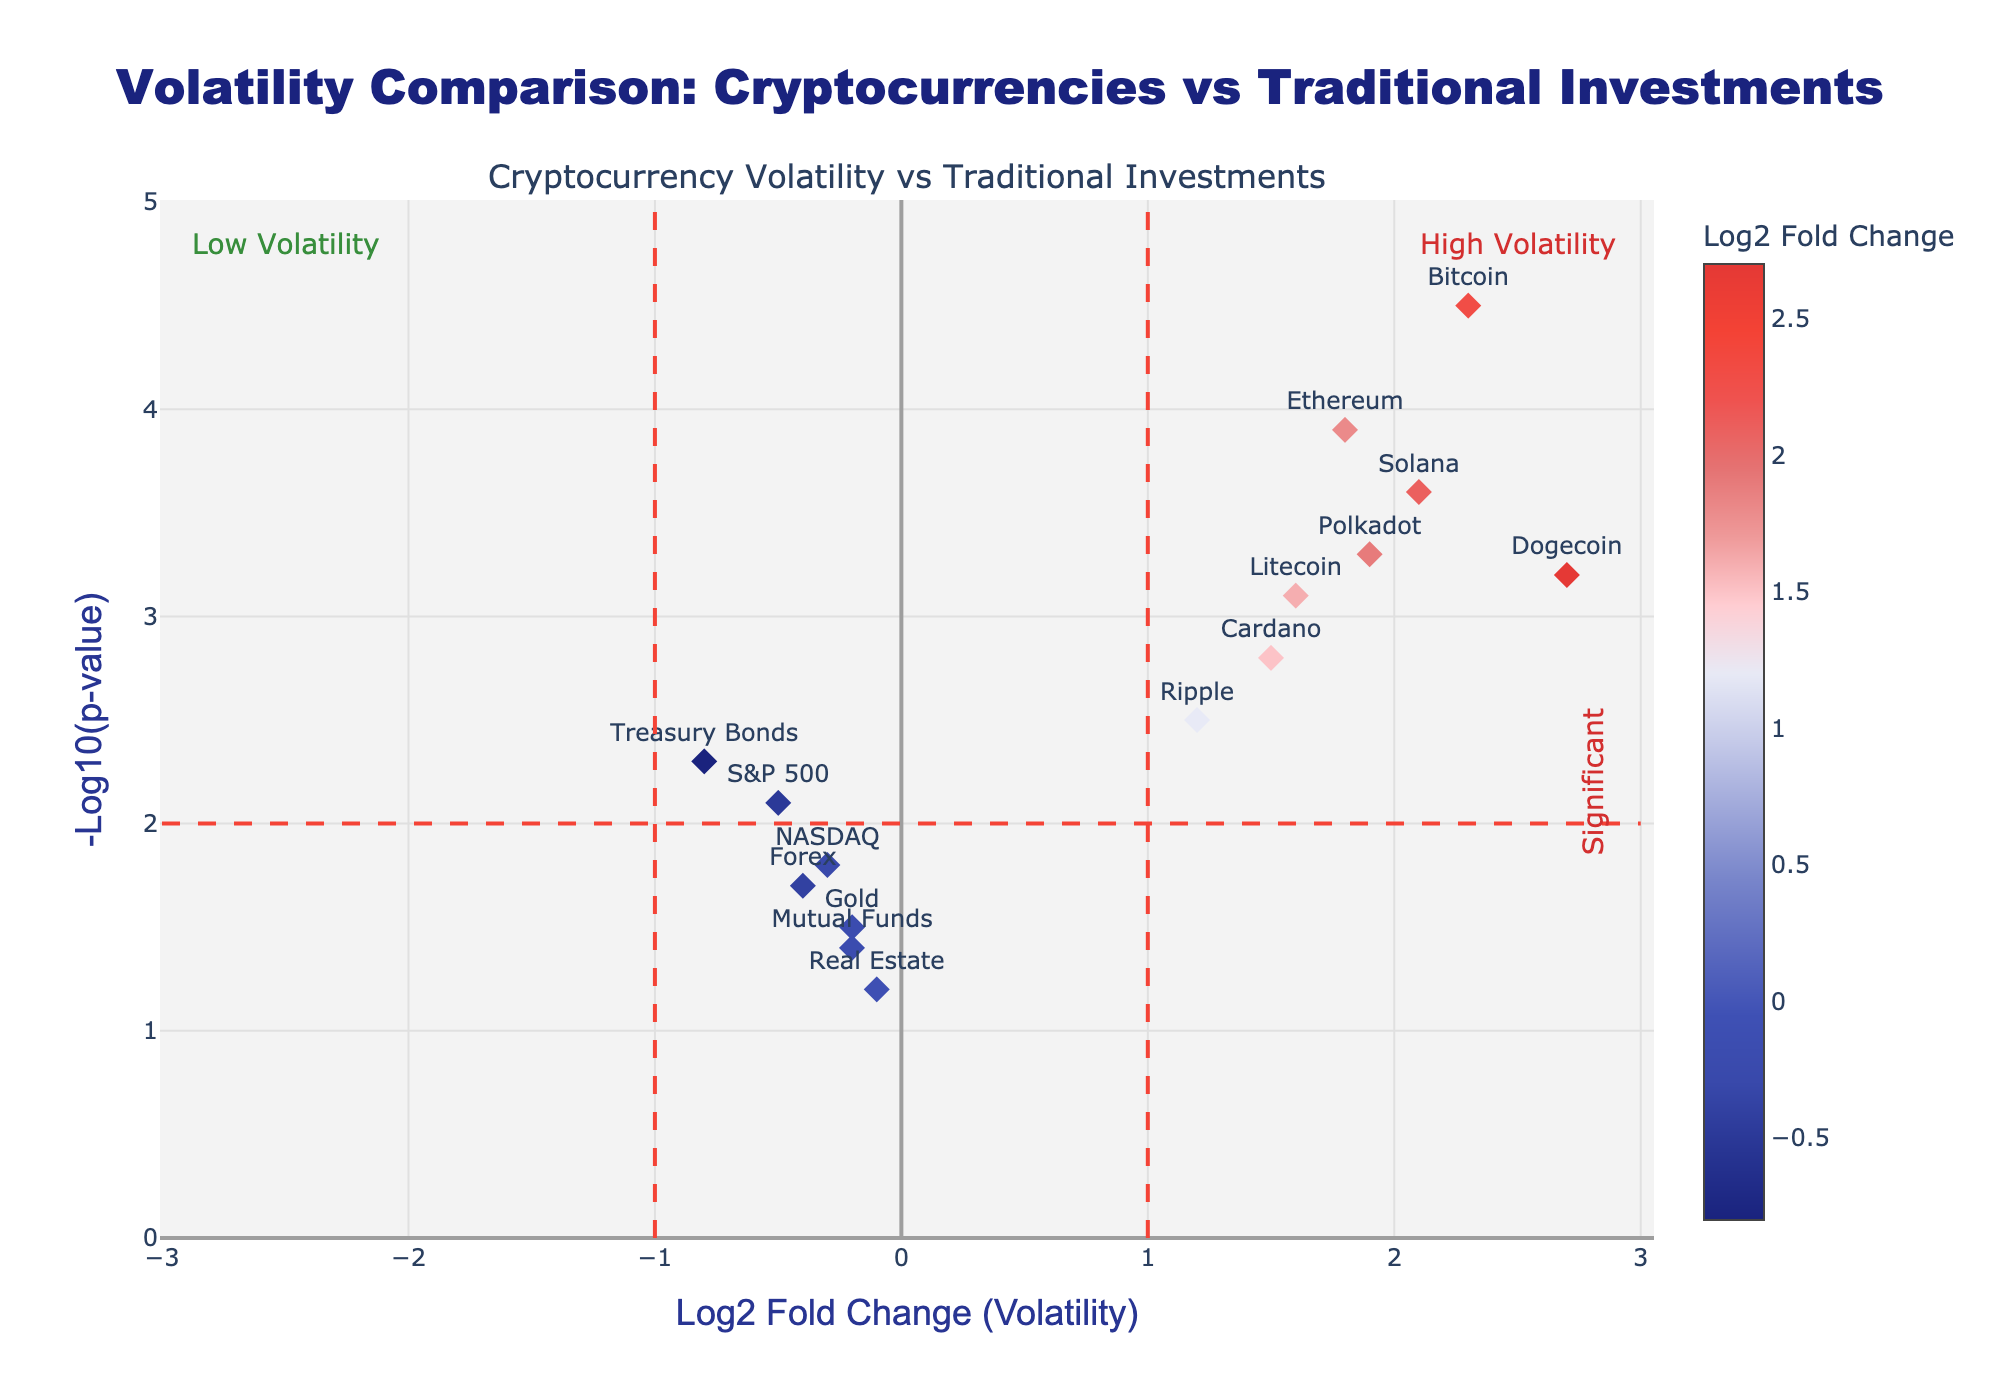what is the title of the plot? The title of the plot is usually at the top and center of the figure. For this volcano plot, the title reads "Volatility Comparison: Cryptocurrencies vs Traditional Investments".
Answer: Volatility Comparison: Cryptocurrencies vs Traditional Investments What do the x-axis and y-axis represent? The x-axis and y-axis titles are typically located along the axis lines. In this plot, the x-axis title reads "Log2 Fold Change (Volatility)" and the y-axis title reads "-Log10(p-value)".
Answer: x-axis: Log2 Fold Change (Volatility), y-axis: -Log10(p-value) Which cryptocurrency has the highest volatility according to the plot? Look for the point with the highest value on the x-axis (Log2 Fold Change). According to the plot, Dogecoin has the highest Log2 Fold Change value of 2.7.
Answer: Dogecoin How many cryptocurrencies have a Log2 Fold Change greater than 1? Check the x-axis and count the points representing cryptocurrencies that are positioned to the right of 1 on the Log2 Fold Change axis. Bitcoin, Ethereum, Dogecoin, Cardano, Litecoin, Solana, and Polkadot are all greater than 1.
Answer: 7 Which traditional investments are showing low volatility? Traditional investments have negative or low positive Log2 Fold Change values. Identify these points on the left of the x-axis: S&P 500, NASDAQ, Gold, Treasury Bonds, Real Estate, Forex, and Mutual Funds.
Answer: S&P 500, NASDAQ, Gold, Treasury Bonds, Real Estate, Forex, Mutual Funds Is there any traditional investment that falls into the "High Volatility" category? The "High Volatility" area is on the right side of the x-axis (positive Log2 Fold Change) and above the p-value threshold line. No traditional investments are in this area; they all have negative or low positive Log2 Fold Change values.
Answer: No What can we infer about the volatility of Bitcoin compared to Gold? Bitcoin's point is much farther to the right (higher Log2 Fold Change) and higher up (more significant p-value) compared to Gold, indicating Bitcoin is significantly more volatile than Gold.
Answer: Bitcoin is more volatile than Gold Which cryptocurrencies have a significant volatility difference compared to traditional investments? Look for cryptocurrencies on the right of the vertical significance threshold line (Log2 Fold Change greater than 1) and compare their positions with traditional investments, which are on the left. Bitcoin, Ethereum, Dogecoin, Cardano, Litecoin, Solana, and Polkadot show significant differences.
Answer: Bitcoin, Ethereum, Dogecoin, Cardano, Litecoin, Solana, Polkadot 